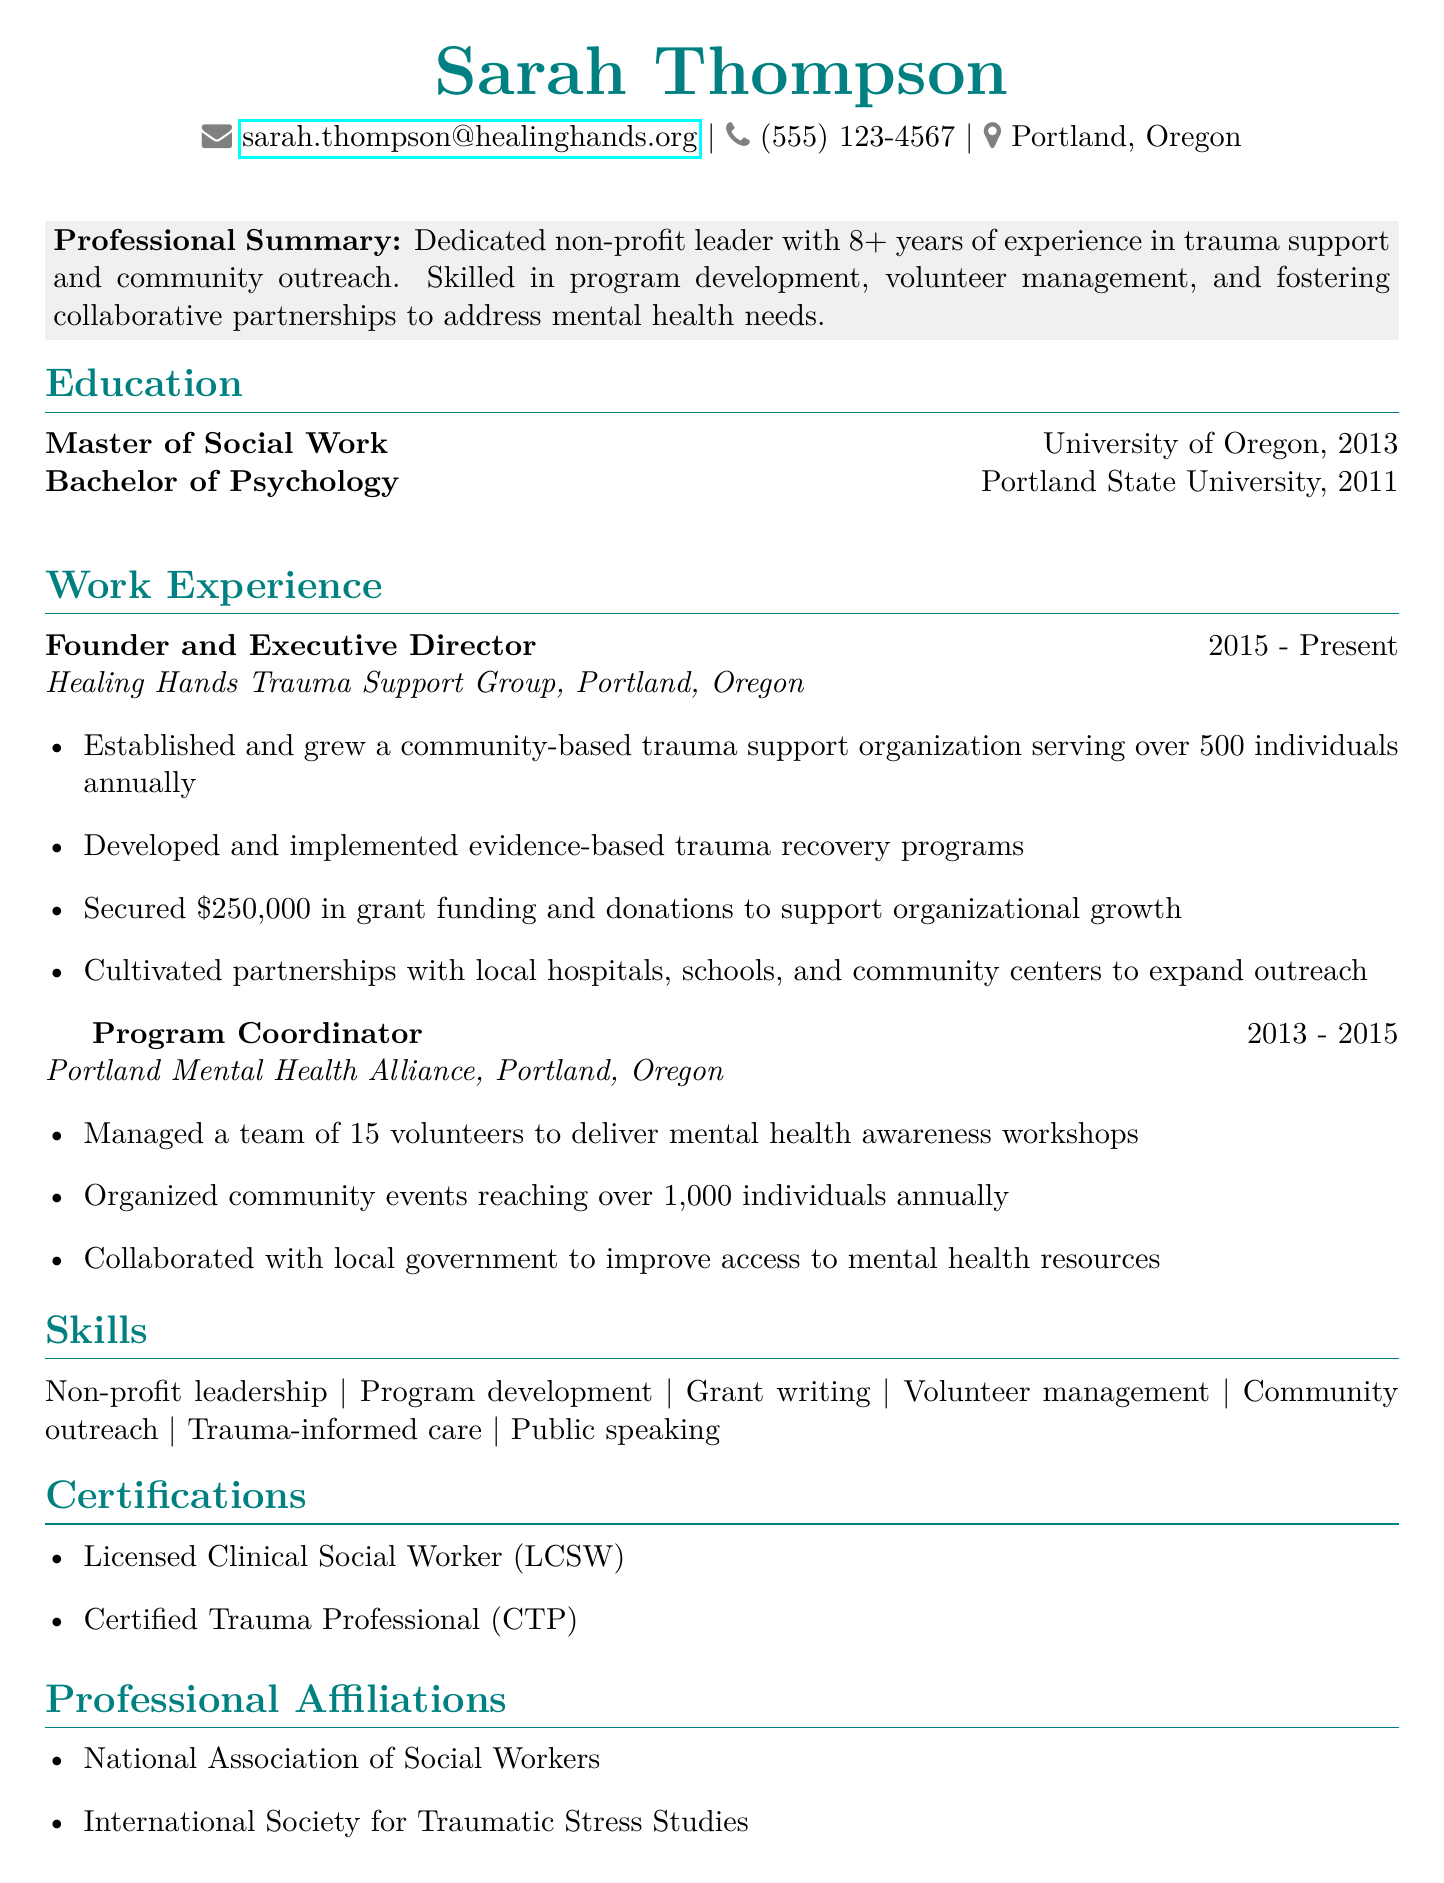what is the name of the founder? The founder's name is mentioned at the top of the document, it lists Sarah Thompson as the individual leading the organization.
Answer: Sarah Thompson what is the highest degree obtained? The highest degree obtained by Sarah Thompson is noted in the education section of the document, specifically the Master's degree mentioned first.
Answer: Master of Social Work what year did Sarah Thompson start Healing Hands Trauma Support Group? The document specifies the duration of her role as starting in 2015, which can be found in the work experience section.
Answer: 2015 how many volunteers did the Program Coordinator manage? The number of volunteers managed is detailed in the responsibilities of the Program Coordinator role, indicating a specific count of personnel.
Answer: 15 volunteers how much grant funding did Sarah secure? The amount of grant funding is specifically mentioned in the responsibilities of her current role, indicating the total she's managed to secure for her organization.
Answer: $250,000 what organization did Sarah coordinate programs for before Healing Hands? The previous organization is referenced in the work experience section under her role before founding Healing Hands, clearly named in that context.
Answer: Portland Mental Health Alliance how many individuals does Healing Hands serve annually? The document states the number of individuals served by Healing Hands annually in a direct description of her responsibilities as Executive Director.
Answer: over 500 individuals which professional affiliation is listed first? The first professional affiliation is mentioned at the end of the CV in the specific section for affiliations, identifying the primary organization she is associated with.
Answer: National Association of Social Workers what skill is linked to Sarah's trauma support expertise? The skills section illustrates her capabilities, where trauma-informed care is specifically noted as relevant to her role and expertise.
Answer: Trauma-informed care 